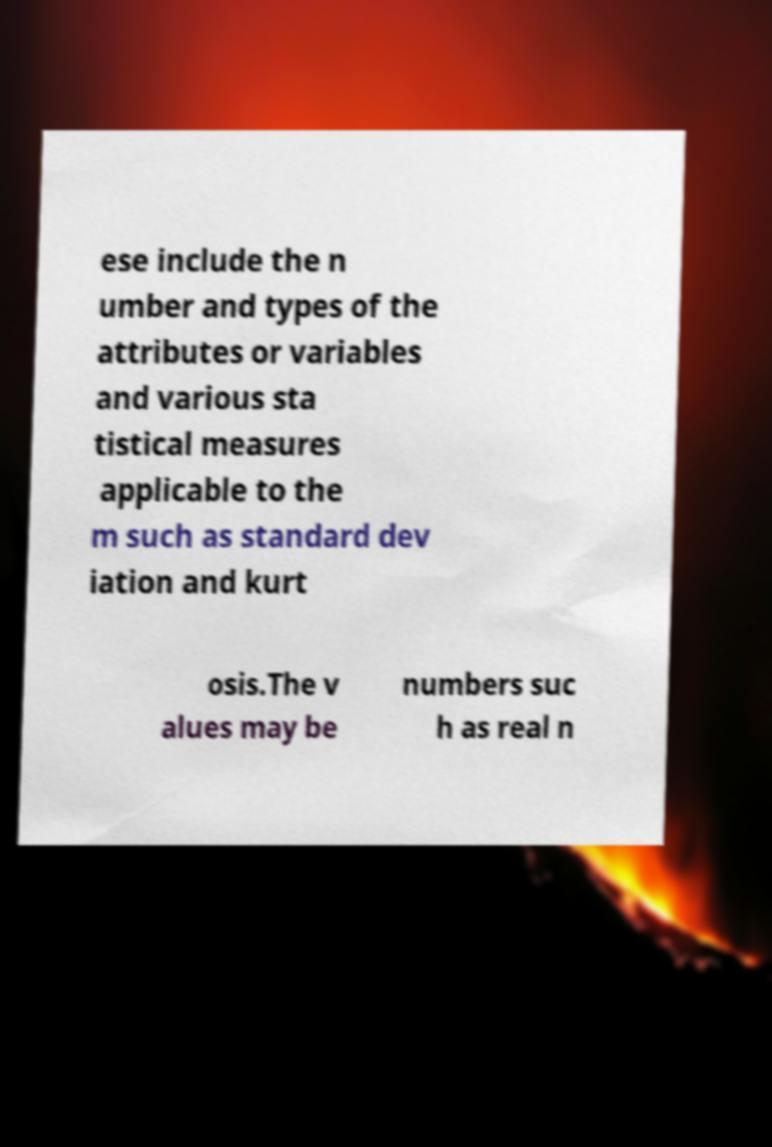Could you assist in decoding the text presented in this image and type it out clearly? ese include the n umber and types of the attributes or variables and various sta tistical measures applicable to the m such as standard dev iation and kurt osis.The v alues may be numbers suc h as real n 